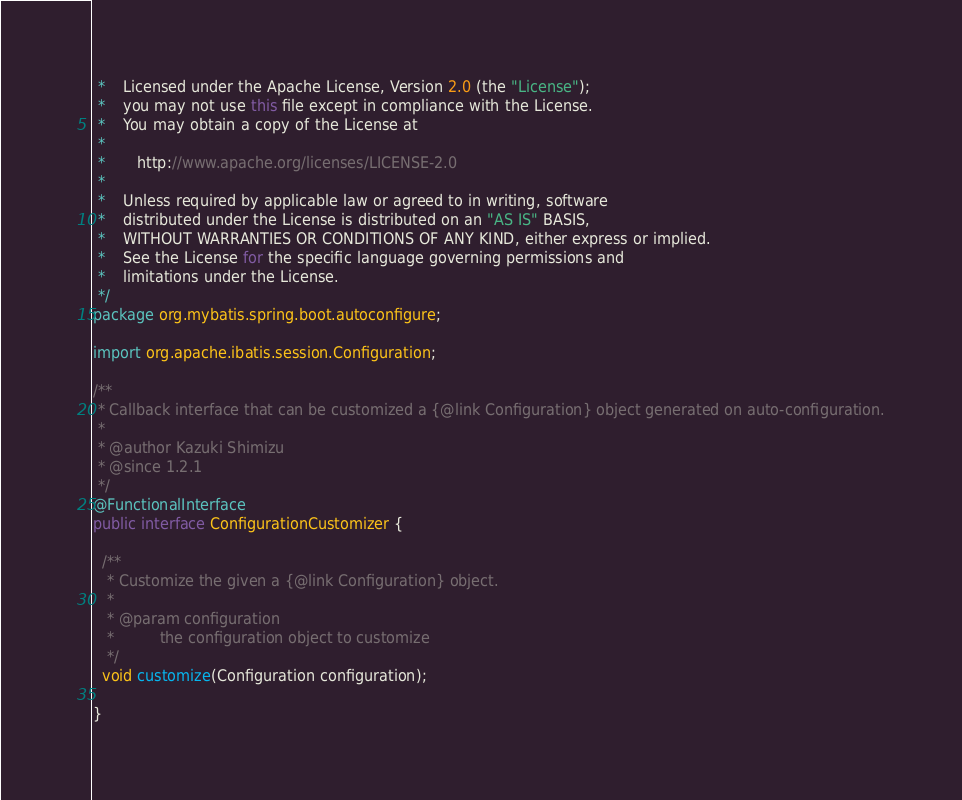Convert code to text. <code><loc_0><loc_0><loc_500><loc_500><_Java_> *    Licensed under the Apache License, Version 2.0 (the "License");
 *    you may not use this file except in compliance with the License.
 *    You may obtain a copy of the License at
 *
 *       http://www.apache.org/licenses/LICENSE-2.0
 *
 *    Unless required by applicable law or agreed to in writing, software
 *    distributed under the License is distributed on an "AS IS" BASIS,
 *    WITHOUT WARRANTIES OR CONDITIONS OF ANY KIND, either express or implied.
 *    See the License for the specific language governing permissions and
 *    limitations under the License.
 */
package org.mybatis.spring.boot.autoconfigure;

import org.apache.ibatis.session.Configuration;

/**
 * Callback interface that can be customized a {@link Configuration} object generated on auto-configuration.
 *
 * @author Kazuki Shimizu
 * @since 1.2.1
 */
@FunctionalInterface
public interface ConfigurationCustomizer {

  /**
   * Customize the given a {@link Configuration} object.
   *
   * @param configuration
   *          the configuration object to customize
   */
  void customize(Configuration configuration);

}
</code> 